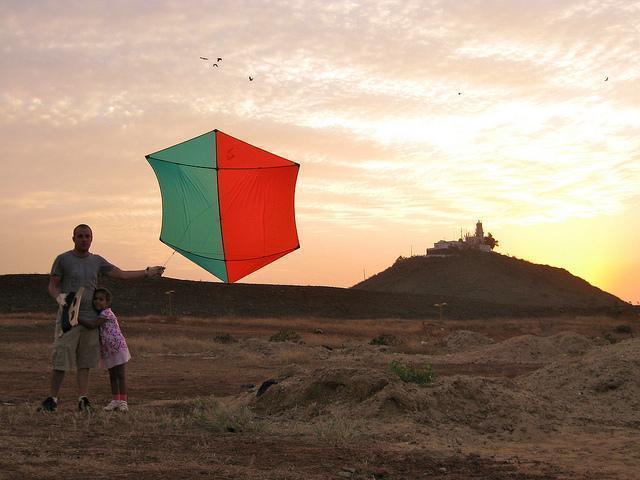What is on the item in the man's right hand?
Choose the correct response and explain in the format: 'Answer: answer
Rationale: rationale.'
Options: Nothing, kite string, dog bone, memo. Answer: kite string.
Rationale: The kite is being held up by the string. 